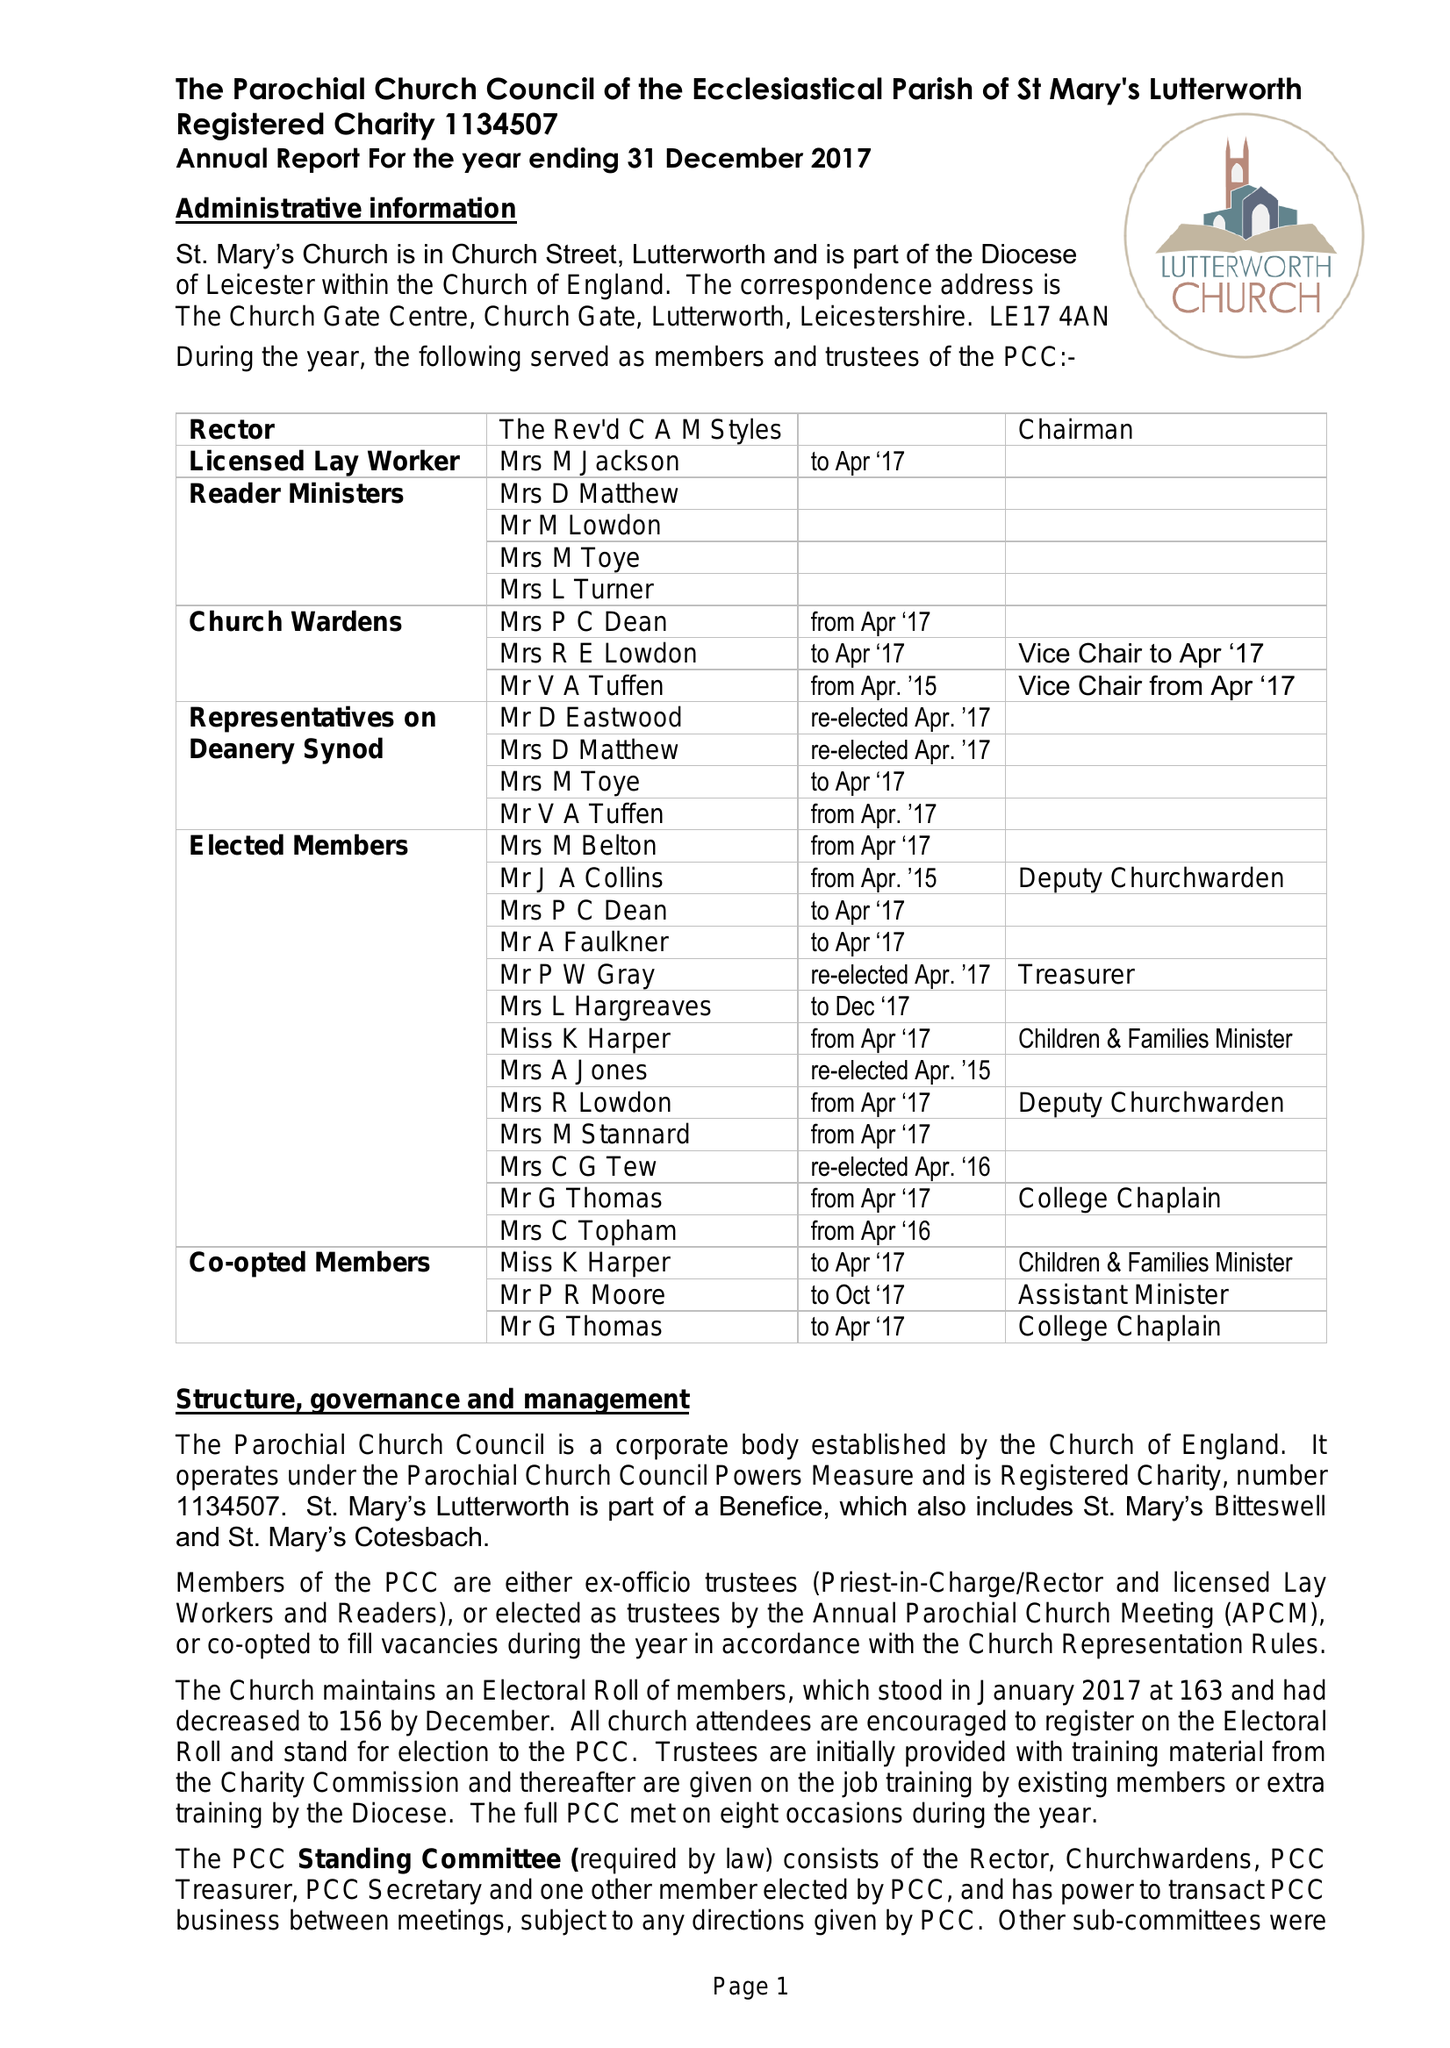What is the value for the charity_name?
Answer the question using a single word or phrase. The Parochial Church Council Of The Ecclesiastical Parish Of St Mary's Lutterworth 